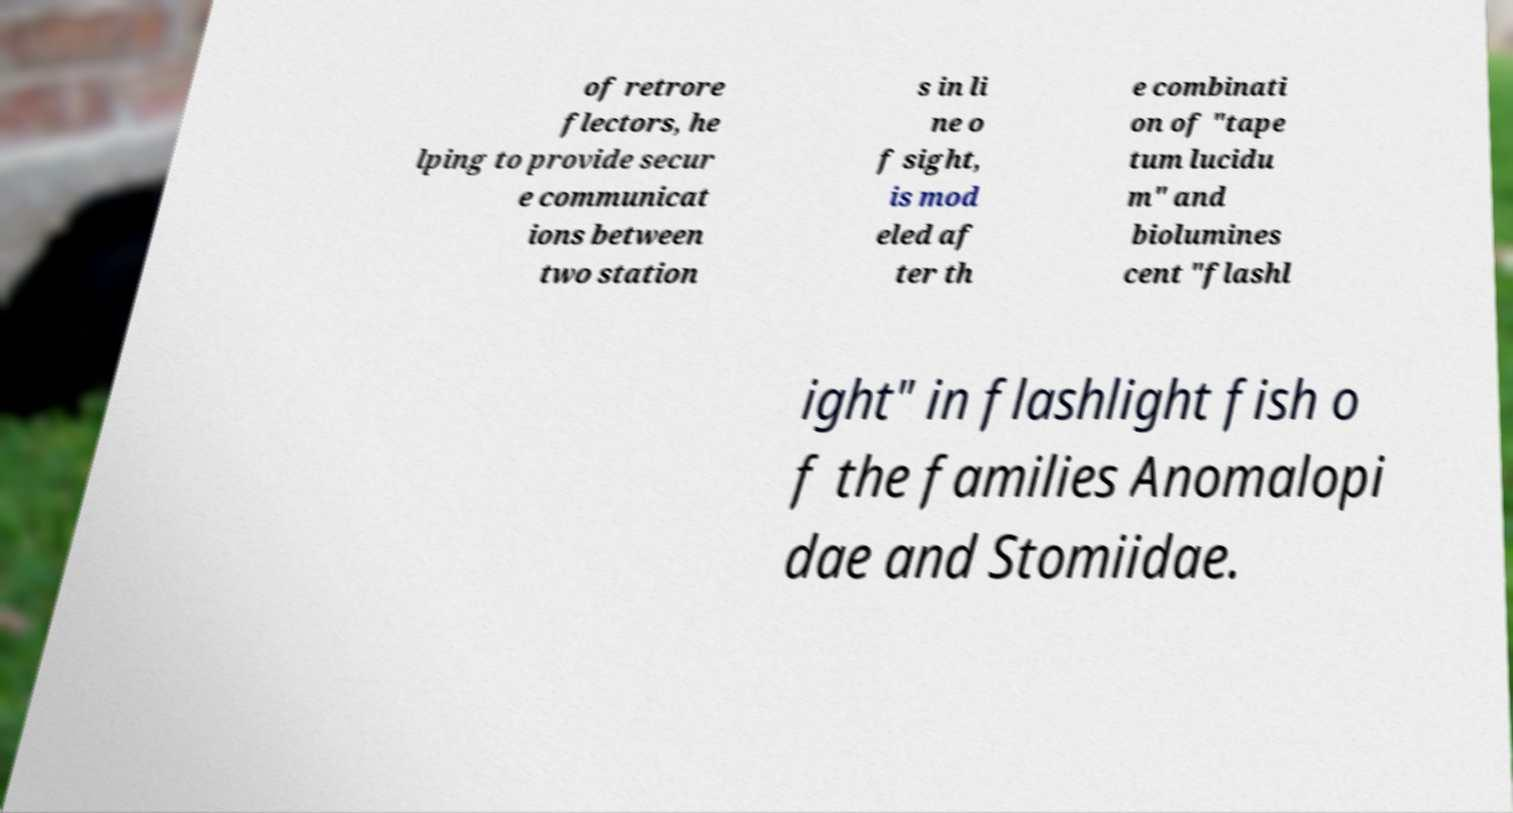Please identify and transcribe the text found in this image. of retrore flectors, he lping to provide secur e communicat ions between two station s in li ne o f sight, is mod eled af ter th e combinati on of "tape tum lucidu m" and biolumines cent "flashl ight" in flashlight fish o f the families Anomalopi dae and Stomiidae. 